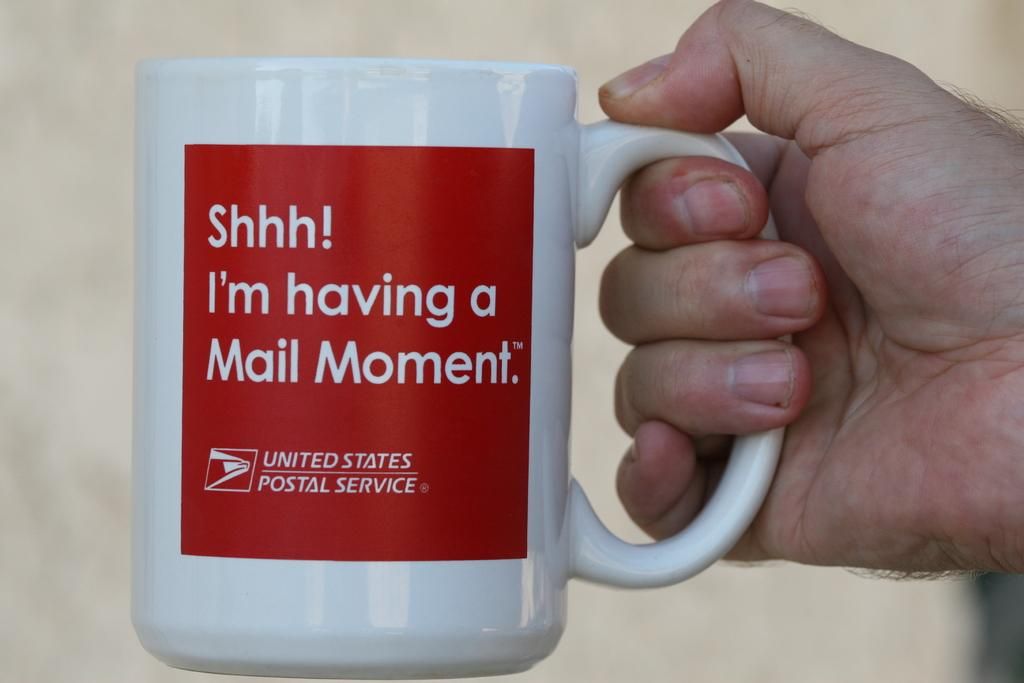<image>
Write a terse but informative summary of the picture. A red and white coffee cup with the USPS logo on it. 